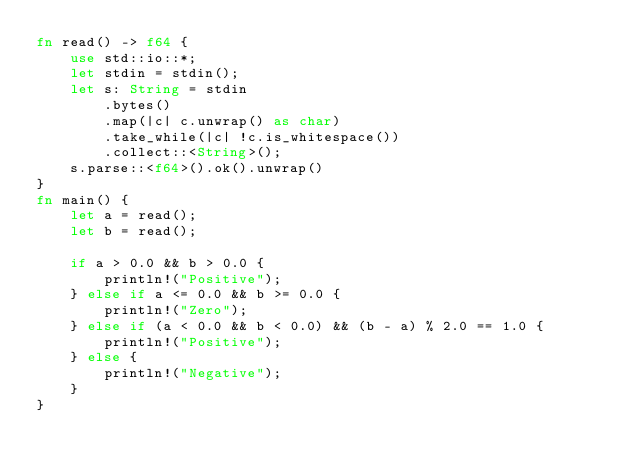<code> <loc_0><loc_0><loc_500><loc_500><_Rust_>fn read() -> f64 {
    use std::io::*;
    let stdin = stdin();
    let s: String = stdin
        .bytes()
        .map(|c| c.unwrap() as char)
        .take_while(|c| !c.is_whitespace())
        .collect::<String>();
    s.parse::<f64>().ok().unwrap()
}
fn main() {
    let a = read();
    let b = read();

    if a > 0.0 && b > 0.0 {
        println!("Positive");
    } else if a <= 0.0 && b >= 0.0 {
        println!("Zero");
    } else if (a < 0.0 && b < 0.0) && (b - a) % 2.0 == 1.0 {
        println!("Positive");
    } else {
        println!("Negative");
    }
}
</code> 